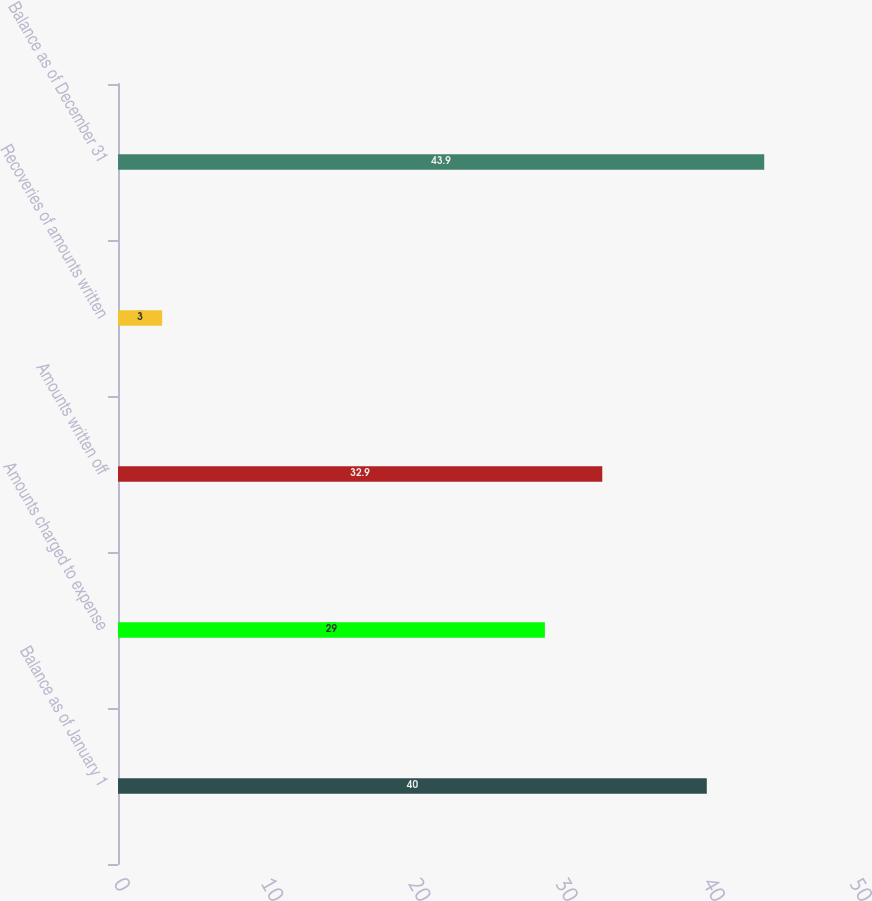Convert chart to OTSL. <chart><loc_0><loc_0><loc_500><loc_500><bar_chart><fcel>Balance as of January 1<fcel>Amounts charged to expense<fcel>Amounts written off<fcel>Recoveries of amounts written<fcel>Balance as of December 31<nl><fcel>40<fcel>29<fcel>32.9<fcel>3<fcel>43.9<nl></chart> 